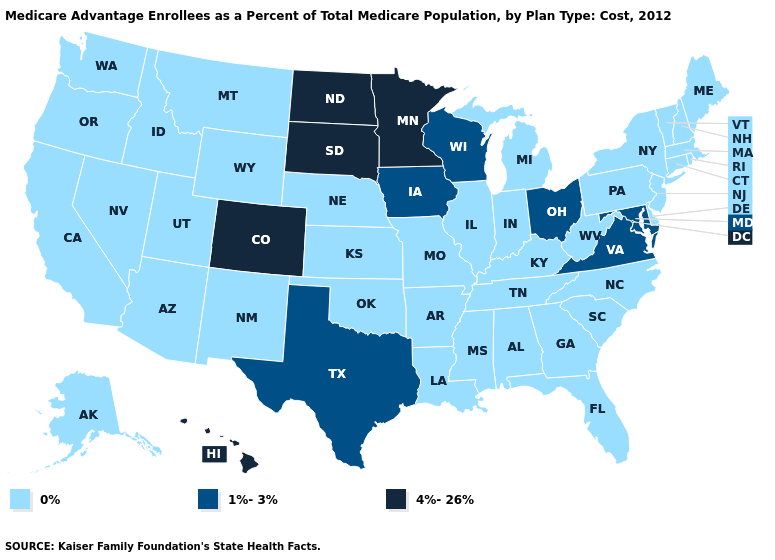Among the states that border North Dakota , does Minnesota have the lowest value?
Concise answer only. No. Name the states that have a value in the range 1%-3%?
Give a very brief answer. Iowa, Maryland, Ohio, Texas, Virginia, Wisconsin. Which states have the lowest value in the Northeast?
Be succinct. Connecticut, Massachusetts, Maine, New Hampshire, New Jersey, New York, Pennsylvania, Rhode Island, Vermont. Among the states that border Virginia , does Kentucky have the highest value?
Answer briefly. No. Which states have the highest value in the USA?
Write a very short answer. Colorado, Hawaii, Minnesota, North Dakota, South Dakota. What is the highest value in the MidWest ?
Give a very brief answer. 4%-26%. What is the lowest value in the South?
Concise answer only. 0%. How many symbols are there in the legend?
Concise answer only. 3. What is the lowest value in the South?
Give a very brief answer. 0%. What is the value of Alaska?
Answer briefly. 0%. Name the states that have a value in the range 4%-26%?
Write a very short answer. Colorado, Hawaii, Minnesota, North Dakota, South Dakota. What is the highest value in the Northeast ?
Be succinct. 0%. What is the value of New Mexico?
Write a very short answer. 0%. Name the states that have a value in the range 0%?
Quick response, please. Alaska, Alabama, Arkansas, Arizona, California, Connecticut, Delaware, Florida, Georgia, Idaho, Illinois, Indiana, Kansas, Kentucky, Louisiana, Massachusetts, Maine, Michigan, Missouri, Mississippi, Montana, North Carolina, Nebraska, New Hampshire, New Jersey, New Mexico, Nevada, New York, Oklahoma, Oregon, Pennsylvania, Rhode Island, South Carolina, Tennessee, Utah, Vermont, Washington, West Virginia, Wyoming. 